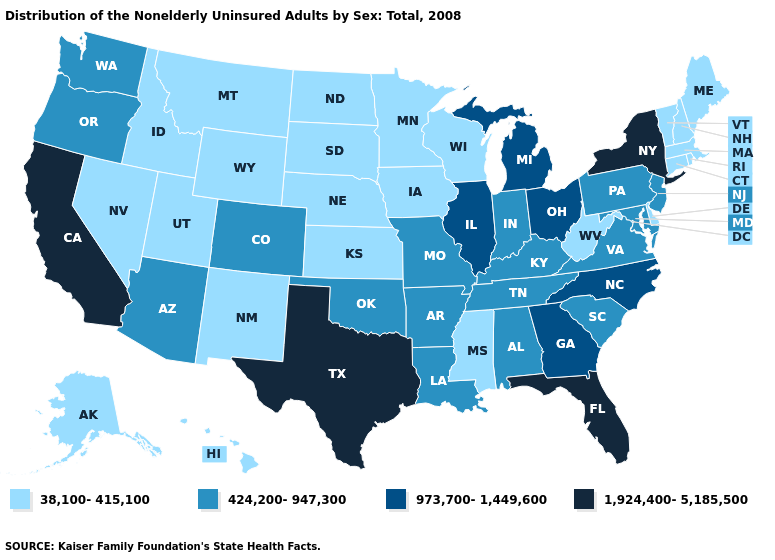Which states have the highest value in the USA?
Keep it brief. California, Florida, New York, Texas. Does Vermont have a lower value than New Hampshire?
Answer briefly. No. Name the states that have a value in the range 38,100-415,100?
Keep it brief. Alaska, Connecticut, Delaware, Hawaii, Idaho, Iowa, Kansas, Maine, Massachusetts, Minnesota, Mississippi, Montana, Nebraska, Nevada, New Hampshire, New Mexico, North Dakota, Rhode Island, South Dakota, Utah, Vermont, West Virginia, Wisconsin, Wyoming. Does the first symbol in the legend represent the smallest category?
Be succinct. Yes. What is the value of Nebraska?
Be succinct. 38,100-415,100. Name the states that have a value in the range 424,200-947,300?
Keep it brief. Alabama, Arizona, Arkansas, Colorado, Indiana, Kentucky, Louisiana, Maryland, Missouri, New Jersey, Oklahoma, Oregon, Pennsylvania, South Carolina, Tennessee, Virginia, Washington. Does Indiana have the lowest value in the MidWest?
Answer briefly. No. Among the states that border Missouri , does Arkansas have the highest value?
Concise answer only. No. Does Utah have the lowest value in the USA?
Short answer required. Yes. Among the states that border Colorado , does Oklahoma have the lowest value?
Keep it brief. No. Among the states that border Louisiana , which have the highest value?
Short answer required. Texas. Name the states that have a value in the range 424,200-947,300?
Be succinct. Alabama, Arizona, Arkansas, Colorado, Indiana, Kentucky, Louisiana, Maryland, Missouri, New Jersey, Oklahoma, Oregon, Pennsylvania, South Carolina, Tennessee, Virginia, Washington. What is the value of Minnesota?
Write a very short answer. 38,100-415,100. Name the states that have a value in the range 38,100-415,100?
Be succinct. Alaska, Connecticut, Delaware, Hawaii, Idaho, Iowa, Kansas, Maine, Massachusetts, Minnesota, Mississippi, Montana, Nebraska, Nevada, New Hampshire, New Mexico, North Dakota, Rhode Island, South Dakota, Utah, Vermont, West Virginia, Wisconsin, Wyoming. What is the value of South Carolina?
Short answer required. 424,200-947,300. 